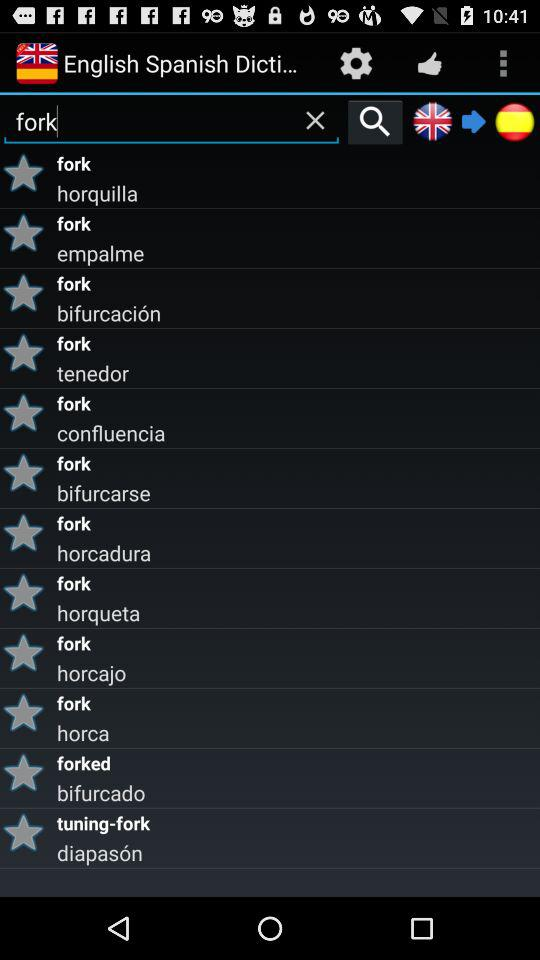What is the text entered in the search bar? The text entered in the search bar is "fork". 